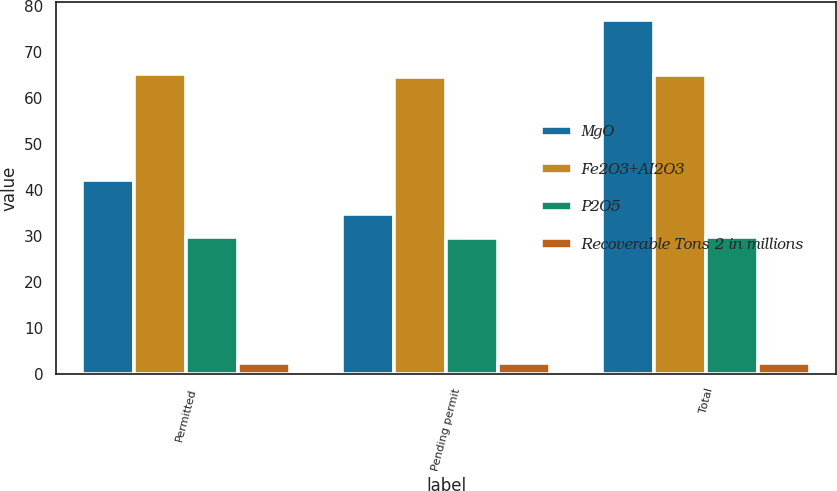Convert chart. <chart><loc_0><loc_0><loc_500><loc_500><stacked_bar_chart><ecel><fcel>Permitted<fcel>Pending permit<fcel>Total<nl><fcel>MgO<fcel>42.2<fcel>34.7<fcel>76.9<nl><fcel>Fe2O3+AI2O3<fcel>65.21<fcel>64.61<fcel>64.94<nl><fcel>P2O5<fcel>29.84<fcel>29.57<fcel>29.72<nl><fcel>Recoverable Tons 2 in millions<fcel>2.38<fcel>2.38<fcel>2.38<nl></chart> 